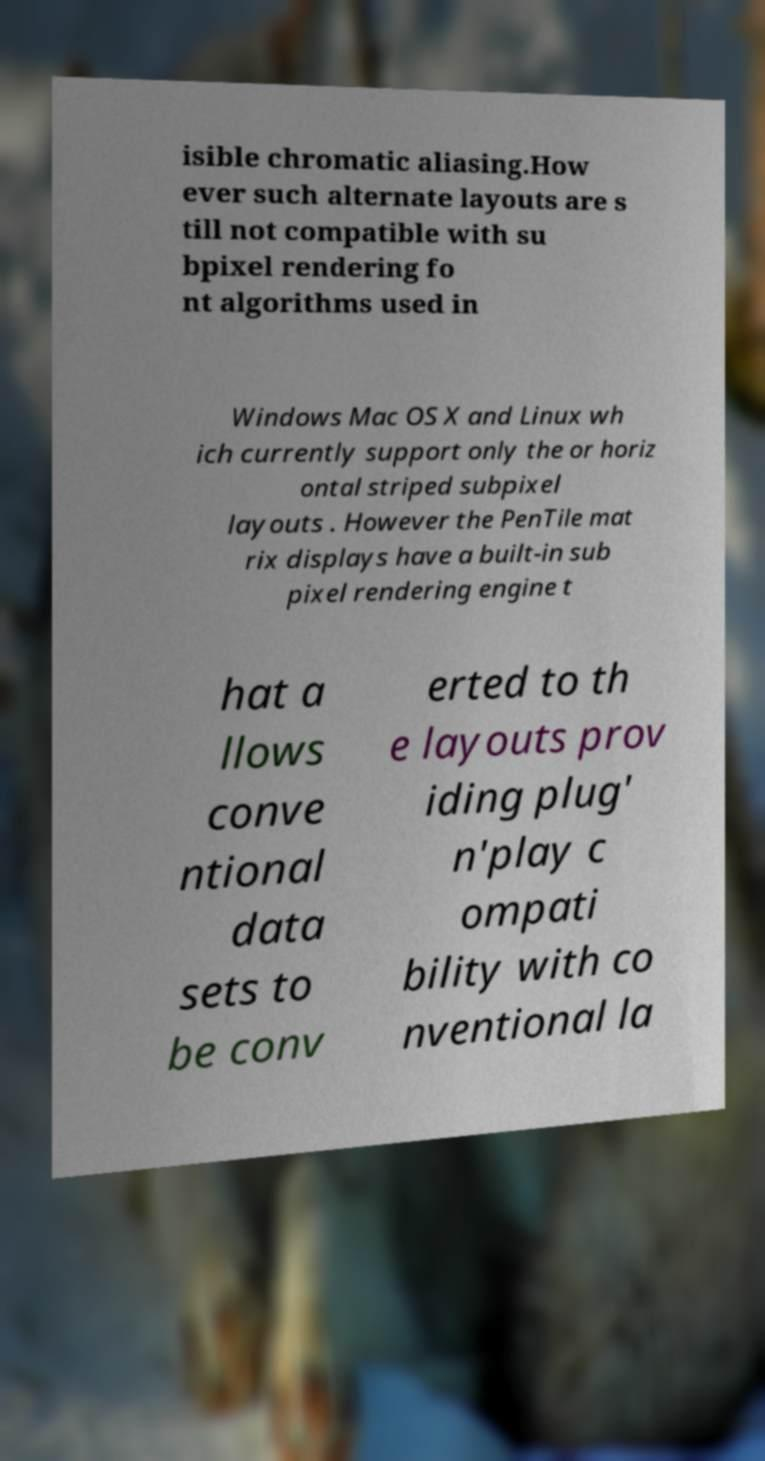What messages or text are displayed in this image? I need them in a readable, typed format. isible chromatic aliasing.How ever such alternate layouts are s till not compatible with su bpixel rendering fo nt algorithms used in Windows Mac OS X and Linux wh ich currently support only the or horiz ontal striped subpixel layouts . However the PenTile mat rix displays have a built-in sub pixel rendering engine t hat a llows conve ntional data sets to be conv erted to th e layouts prov iding plug' n'play c ompati bility with co nventional la 